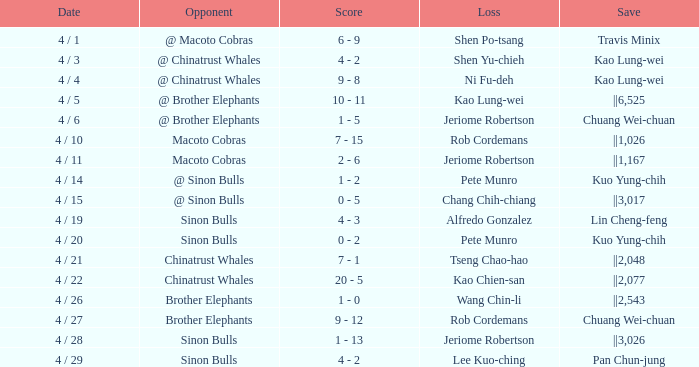Who earned the save in the game against the Sinon Bulls when Jeriome Robertson took the loss? ||3,026. Would you mind parsing the complete table? {'header': ['Date', 'Opponent', 'Score', 'Loss', 'Save'], 'rows': [['4 / 1', '@ Macoto Cobras', '6 - 9', 'Shen Po-tsang', 'Travis Minix'], ['4 / 3', '@ Chinatrust Whales', '4 - 2', 'Shen Yu-chieh', 'Kao Lung-wei'], ['4 / 4', '@ Chinatrust Whales', '9 - 8', 'Ni Fu-deh', 'Kao Lung-wei'], ['4 / 5', '@ Brother Elephants', '10 - 11', 'Kao Lung-wei', '||6,525'], ['4 / 6', '@ Brother Elephants', '1 - 5', 'Jeriome Robertson', 'Chuang Wei-chuan'], ['4 / 10', 'Macoto Cobras', '7 - 15', 'Rob Cordemans', '||1,026'], ['4 / 11', 'Macoto Cobras', '2 - 6', 'Jeriome Robertson', '||1,167'], ['4 / 14', '@ Sinon Bulls', '1 - 2', 'Pete Munro', 'Kuo Yung-chih'], ['4 / 15', '@ Sinon Bulls', '0 - 5', 'Chang Chih-chiang', '||3,017'], ['4 / 19', 'Sinon Bulls', '4 - 3', 'Alfredo Gonzalez', 'Lin Cheng-feng'], ['4 / 20', 'Sinon Bulls', '0 - 2', 'Pete Munro', 'Kuo Yung-chih'], ['4 / 21', 'Chinatrust Whales', '7 - 1', 'Tseng Chao-hao', '||2,048'], ['4 / 22', 'Chinatrust Whales', '20 - 5', 'Kao Chien-san', '||2,077'], ['4 / 26', 'Brother Elephants', '1 - 0', 'Wang Chin-li', '||2,543'], ['4 / 27', 'Brother Elephants', '9 - 12', 'Rob Cordemans', 'Chuang Wei-chuan'], ['4 / 28', 'Sinon Bulls', '1 - 13', 'Jeriome Robertson', '||3,026'], ['4 / 29', 'Sinon Bulls', '4 - 2', 'Lee Kuo-ching', 'Pan Chun-jung']]} 